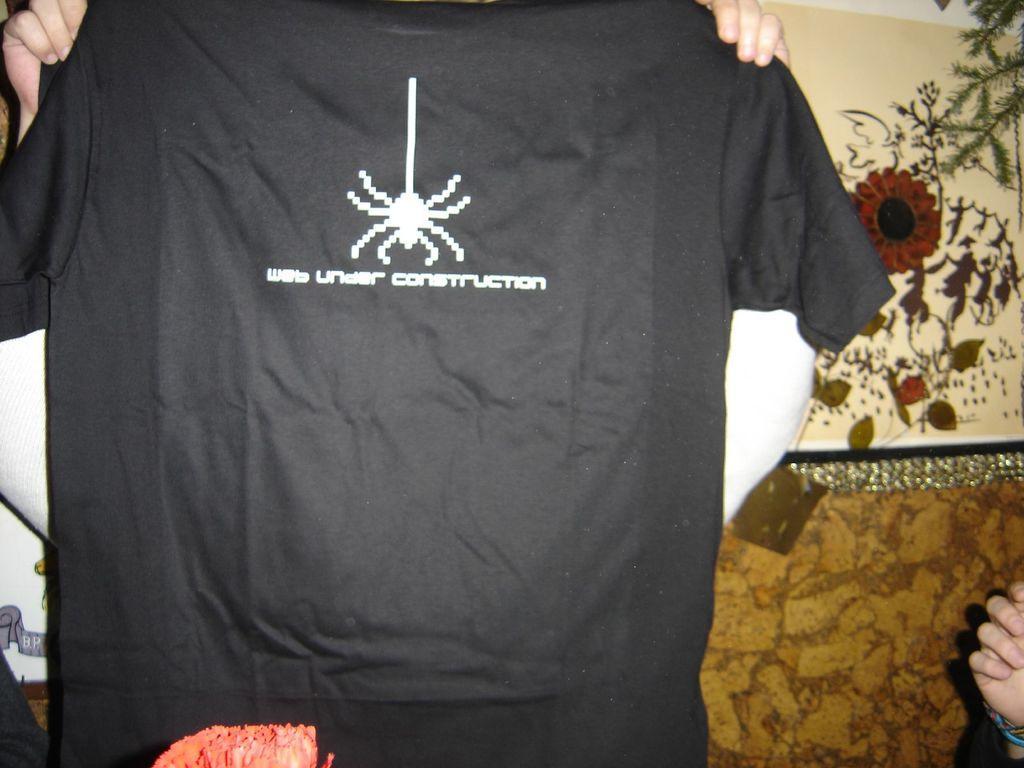Can you describe this image briefly? In the image there is a black t-shirt with an image and something written on it. There are hands of the person holding the t-shirt. In the background there are flowers and leaves. On the right side of the image there is a person hand. At the bottom of the image there is a pink color object. 